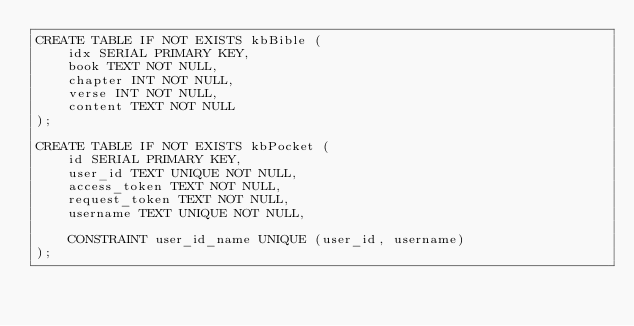Convert code to text. <code><loc_0><loc_0><loc_500><loc_500><_SQL_>CREATE TABLE IF NOT EXISTS kbBible (
    idx SERIAL PRIMARY KEY,
    book TEXT NOT NULL,
    chapter INT NOT NULL,
    verse INT NOT NULL,
    content TEXT NOT NULL
);

CREATE TABLE IF NOT EXISTS kbPocket (
    id SERIAL PRIMARY KEY,
    user_id TEXT UNIQUE NOT NULL,
    access_token TEXT NOT NULL,
    request_token TEXT NOT NULL,
    username TEXT UNIQUE NOT NULL,

    CONSTRAINT user_id_name UNIQUE (user_id, username)
);</code> 